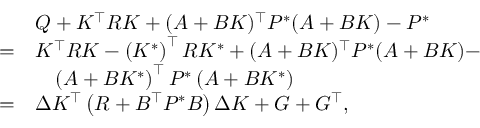<formula> <loc_0><loc_0><loc_500><loc_500>\begin{array} { r l } & { Q + { K } ^ { \top } R { K } + ( A + B { K } ) ^ { \top } P ^ { * } ( A + B { K } ) - P ^ { * } } \\ { = } & { { K } ^ { \top } R { K } - \left ( { K ^ { * } } \right ) ^ { \top } R K ^ { * } + ( A + B { K } ) ^ { \top } P ^ { * } ( A + B { K } ) - } \\ & { \quad \left ( A + B K ^ { * } \right ) ^ { \top } P ^ { * } \left ( A + B K ^ { * } \right ) } \\ { = } & { \Delta K ^ { \top } \left ( R + B ^ { \top } P ^ { * } B \right ) \Delta K + G + G ^ { \top } , } \end{array}</formula> 